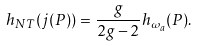<formula> <loc_0><loc_0><loc_500><loc_500>h _ { N T } ( j ( P ) ) = \frac { g } { 2 g - 2 } h _ { \omega _ { a } } ( P ) .</formula> 